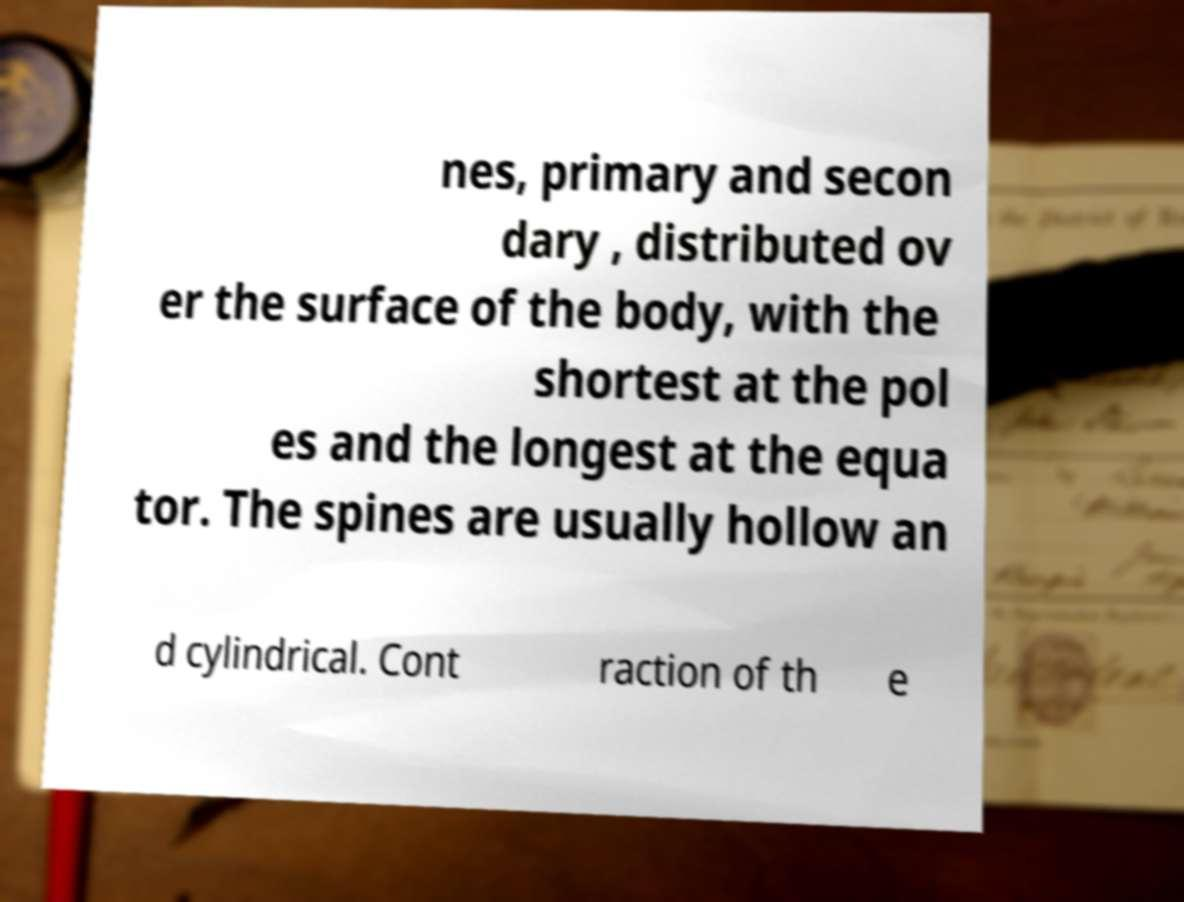I need the written content from this picture converted into text. Can you do that? nes, primary and secon dary , distributed ov er the surface of the body, with the shortest at the pol es and the longest at the equa tor. The spines are usually hollow an d cylindrical. Cont raction of th e 